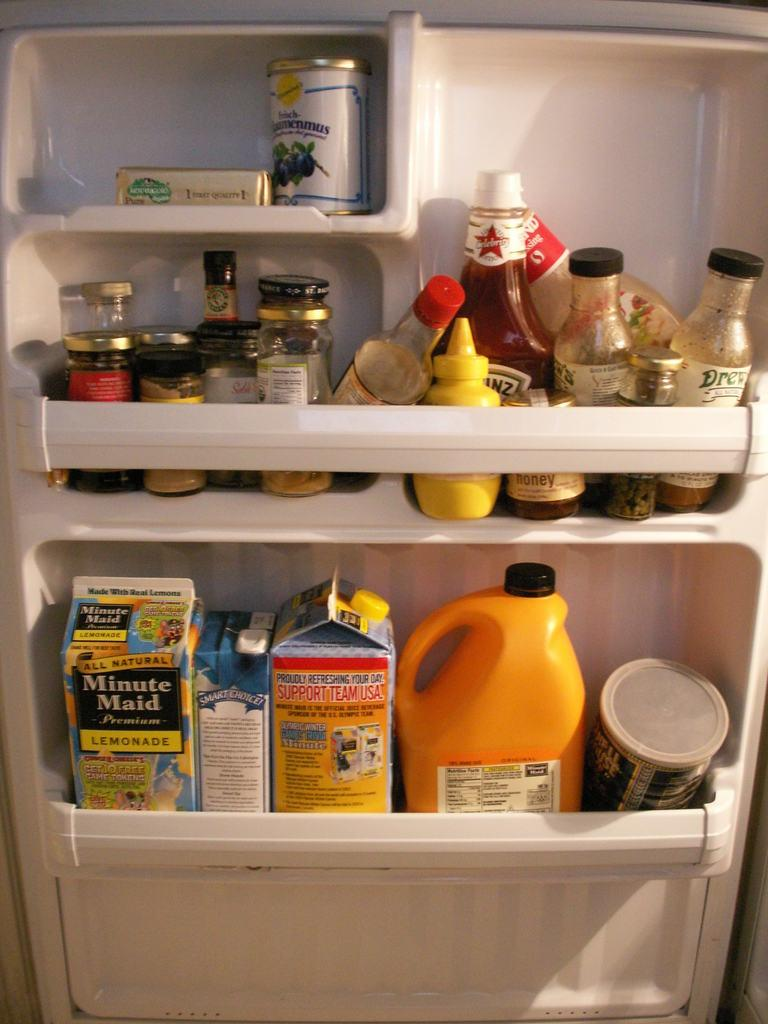<image>
Provide a brief description of the given image. A refrigerator door that holds various items, from Heinz ketchup to Minute Maid lemonade. 